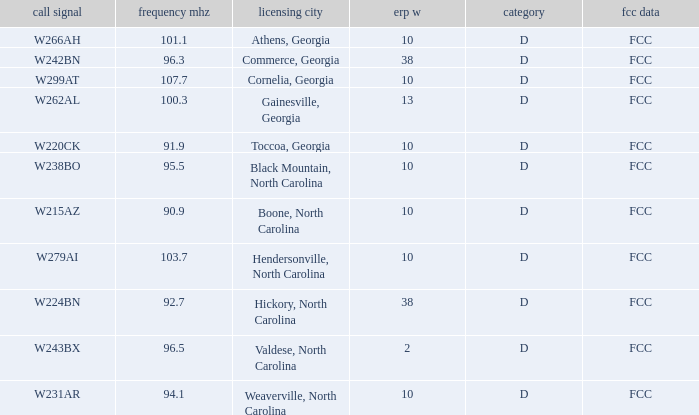What class is the city of black mountain, north carolina? D. 